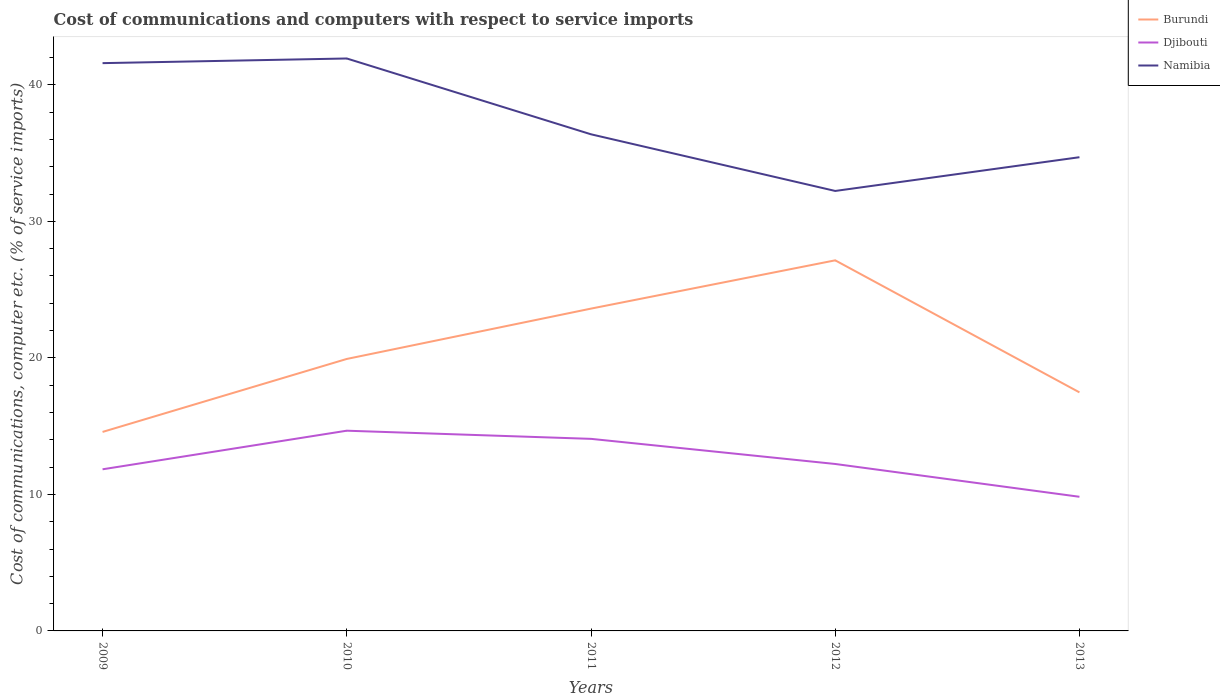How many different coloured lines are there?
Offer a terse response. 3. Across all years, what is the maximum cost of communications and computers in Namibia?
Make the answer very short. 32.23. In which year was the cost of communications and computers in Djibouti maximum?
Your response must be concise. 2013. What is the total cost of communications and computers in Djibouti in the graph?
Your answer should be very brief. -2.23. What is the difference between the highest and the second highest cost of communications and computers in Burundi?
Provide a short and direct response. 12.57. Is the cost of communications and computers in Burundi strictly greater than the cost of communications and computers in Djibouti over the years?
Ensure brevity in your answer.  No. How many years are there in the graph?
Ensure brevity in your answer.  5. Are the values on the major ticks of Y-axis written in scientific E-notation?
Your answer should be very brief. No. Does the graph contain grids?
Provide a short and direct response. No. Where does the legend appear in the graph?
Give a very brief answer. Top right. How many legend labels are there?
Keep it short and to the point. 3. How are the legend labels stacked?
Offer a very short reply. Vertical. What is the title of the graph?
Ensure brevity in your answer.  Cost of communications and computers with respect to service imports. What is the label or title of the X-axis?
Your answer should be very brief. Years. What is the label or title of the Y-axis?
Offer a terse response. Cost of communications, computer etc. (% of service imports). What is the Cost of communications, computer etc. (% of service imports) of Burundi in 2009?
Offer a very short reply. 14.58. What is the Cost of communications, computer etc. (% of service imports) of Djibouti in 2009?
Provide a short and direct response. 11.84. What is the Cost of communications, computer etc. (% of service imports) of Namibia in 2009?
Ensure brevity in your answer.  41.59. What is the Cost of communications, computer etc. (% of service imports) of Burundi in 2010?
Offer a terse response. 19.92. What is the Cost of communications, computer etc. (% of service imports) in Djibouti in 2010?
Give a very brief answer. 14.67. What is the Cost of communications, computer etc. (% of service imports) in Namibia in 2010?
Ensure brevity in your answer.  41.93. What is the Cost of communications, computer etc. (% of service imports) in Burundi in 2011?
Keep it short and to the point. 23.61. What is the Cost of communications, computer etc. (% of service imports) in Djibouti in 2011?
Your answer should be compact. 14.07. What is the Cost of communications, computer etc. (% of service imports) in Namibia in 2011?
Your response must be concise. 36.38. What is the Cost of communications, computer etc. (% of service imports) of Burundi in 2012?
Make the answer very short. 27.15. What is the Cost of communications, computer etc. (% of service imports) in Djibouti in 2012?
Make the answer very short. 12.23. What is the Cost of communications, computer etc. (% of service imports) of Namibia in 2012?
Provide a short and direct response. 32.23. What is the Cost of communications, computer etc. (% of service imports) of Burundi in 2013?
Your answer should be compact. 17.48. What is the Cost of communications, computer etc. (% of service imports) in Djibouti in 2013?
Provide a short and direct response. 9.83. What is the Cost of communications, computer etc. (% of service imports) in Namibia in 2013?
Make the answer very short. 34.7. Across all years, what is the maximum Cost of communications, computer etc. (% of service imports) of Burundi?
Give a very brief answer. 27.15. Across all years, what is the maximum Cost of communications, computer etc. (% of service imports) of Djibouti?
Give a very brief answer. 14.67. Across all years, what is the maximum Cost of communications, computer etc. (% of service imports) in Namibia?
Your response must be concise. 41.93. Across all years, what is the minimum Cost of communications, computer etc. (% of service imports) in Burundi?
Offer a terse response. 14.58. Across all years, what is the minimum Cost of communications, computer etc. (% of service imports) of Djibouti?
Provide a short and direct response. 9.83. Across all years, what is the minimum Cost of communications, computer etc. (% of service imports) in Namibia?
Ensure brevity in your answer.  32.23. What is the total Cost of communications, computer etc. (% of service imports) in Burundi in the graph?
Ensure brevity in your answer.  102.73. What is the total Cost of communications, computer etc. (% of service imports) in Djibouti in the graph?
Provide a succinct answer. 62.63. What is the total Cost of communications, computer etc. (% of service imports) in Namibia in the graph?
Offer a very short reply. 186.83. What is the difference between the Cost of communications, computer etc. (% of service imports) of Burundi in 2009 and that in 2010?
Offer a very short reply. -5.35. What is the difference between the Cost of communications, computer etc. (% of service imports) in Djibouti in 2009 and that in 2010?
Provide a succinct answer. -2.83. What is the difference between the Cost of communications, computer etc. (% of service imports) of Namibia in 2009 and that in 2010?
Provide a short and direct response. -0.34. What is the difference between the Cost of communications, computer etc. (% of service imports) of Burundi in 2009 and that in 2011?
Provide a succinct answer. -9.03. What is the difference between the Cost of communications, computer etc. (% of service imports) in Djibouti in 2009 and that in 2011?
Ensure brevity in your answer.  -2.23. What is the difference between the Cost of communications, computer etc. (% of service imports) in Namibia in 2009 and that in 2011?
Give a very brief answer. 5.21. What is the difference between the Cost of communications, computer etc. (% of service imports) in Burundi in 2009 and that in 2012?
Your response must be concise. -12.57. What is the difference between the Cost of communications, computer etc. (% of service imports) in Djibouti in 2009 and that in 2012?
Your response must be concise. -0.39. What is the difference between the Cost of communications, computer etc. (% of service imports) in Namibia in 2009 and that in 2012?
Ensure brevity in your answer.  9.36. What is the difference between the Cost of communications, computer etc. (% of service imports) in Burundi in 2009 and that in 2013?
Provide a short and direct response. -2.9. What is the difference between the Cost of communications, computer etc. (% of service imports) in Djibouti in 2009 and that in 2013?
Your response must be concise. 2.01. What is the difference between the Cost of communications, computer etc. (% of service imports) of Namibia in 2009 and that in 2013?
Make the answer very short. 6.89. What is the difference between the Cost of communications, computer etc. (% of service imports) in Burundi in 2010 and that in 2011?
Your answer should be very brief. -3.69. What is the difference between the Cost of communications, computer etc. (% of service imports) of Djibouti in 2010 and that in 2011?
Ensure brevity in your answer.  0.6. What is the difference between the Cost of communications, computer etc. (% of service imports) in Namibia in 2010 and that in 2011?
Keep it short and to the point. 5.55. What is the difference between the Cost of communications, computer etc. (% of service imports) in Burundi in 2010 and that in 2012?
Your answer should be compact. -7.22. What is the difference between the Cost of communications, computer etc. (% of service imports) of Djibouti in 2010 and that in 2012?
Make the answer very short. 2.44. What is the difference between the Cost of communications, computer etc. (% of service imports) of Namibia in 2010 and that in 2012?
Your response must be concise. 9.7. What is the difference between the Cost of communications, computer etc. (% of service imports) in Burundi in 2010 and that in 2013?
Offer a terse response. 2.45. What is the difference between the Cost of communications, computer etc. (% of service imports) in Djibouti in 2010 and that in 2013?
Keep it short and to the point. 4.84. What is the difference between the Cost of communications, computer etc. (% of service imports) of Namibia in 2010 and that in 2013?
Provide a short and direct response. 7.23. What is the difference between the Cost of communications, computer etc. (% of service imports) in Burundi in 2011 and that in 2012?
Your answer should be very brief. -3.54. What is the difference between the Cost of communications, computer etc. (% of service imports) in Djibouti in 2011 and that in 2012?
Provide a succinct answer. 1.84. What is the difference between the Cost of communications, computer etc. (% of service imports) of Namibia in 2011 and that in 2012?
Provide a short and direct response. 4.15. What is the difference between the Cost of communications, computer etc. (% of service imports) of Burundi in 2011 and that in 2013?
Provide a succinct answer. 6.14. What is the difference between the Cost of communications, computer etc. (% of service imports) in Djibouti in 2011 and that in 2013?
Give a very brief answer. 4.24. What is the difference between the Cost of communications, computer etc. (% of service imports) in Namibia in 2011 and that in 2013?
Your answer should be compact. 1.68. What is the difference between the Cost of communications, computer etc. (% of service imports) in Burundi in 2012 and that in 2013?
Offer a very short reply. 9.67. What is the difference between the Cost of communications, computer etc. (% of service imports) in Djibouti in 2012 and that in 2013?
Offer a terse response. 2.4. What is the difference between the Cost of communications, computer etc. (% of service imports) of Namibia in 2012 and that in 2013?
Make the answer very short. -2.47. What is the difference between the Cost of communications, computer etc. (% of service imports) in Burundi in 2009 and the Cost of communications, computer etc. (% of service imports) in Djibouti in 2010?
Ensure brevity in your answer.  -0.09. What is the difference between the Cost of communications, computer etc. (% of service imports) of Burundi in 2009 and the Cost of communications, computer etc. (% of service imports) of Namibia in 2010?
Your response must be concise. -27.36. What is the difference between the Cost of communications, computer etc. (% of service imports) of Djibouti in 2009 and the Cost of communications, computer etc. (% of service imports) of Namibia in 2010?
Your answer should be very brief. -30.09. What is the difference between the Cost of communications, computer etc. (% of service imports) of Burundi in 2009 and the Cost of communications, computer etc. (% of service imports) of Djibouti in 2011?
Keep it short and to the point. 0.51. What is the difference between the Cost of communications, computer etc. (% of service imports) in Burundi in 2009 and the Cost of communications, computer etc. (% of service imports) in Namibia in 2011?
Your answer should be compact. -21.8. What is the difference between the Cost of communications, computer etc. (% of service imports) of Djibouti in 2009 and the Cost of communications, computer etc. (% of service imports) of Namibia in 2011?
Offer a very short reply. -24.54. What is the difference between the Cost of communications, computer etc. (% of service imports) in Burundi in 2009 and the Cost of communications, computer etc. (% of service imports) in Djibouti in 2012?
Your answer should be compact. 2.35. What is the difference between the Cost of communications, computer etc. (% of service imports) of Burundi in 2009 and the Cost of communications, computer etc. (% of service imports) of Namibia in 2012?
Your answer should be compact. -17.65. What is the difference between the Cost of communications, computer etc. (% of service imports) of Djibouti in 2009 and the Cost of communications, computer etc. (% of service imports) of Namibia in 2012?
Provide a short and direct response. -20.39. What is the difference between the Cost of communications, computer etc. (% of service imports) of Burundi in 2009 and the Cost of communications, computer etc. (% of service imports) of Djibouti in 2013?
Ensure brevity in your answer.  4.75. What is the difference between the Cost of communications, computer etc. (% of service imports) of Burundi in 2009 and the Cost of communications, computer etc. (% of service imports) of Namibia in 2013?
Your answer should be compact. -20.12. What is the difference between the Cost of communications, computer etc. (% of service imports) in Djibouti in 2009 and the Cost of communications, computer etc. (% of service imports) in Namibia in 2013?
Offer a very short reply. -22.86. What is the difference between the Cost of communications, computer etc. (% of service imports) in Burundi in 2010 and the Cost of communications, computer etc. (% of service imports) in Djibouti in 2011?
Offer a terse response. 5.85. What is the difference between the Cost of communications, computer etc. (% of service imports) of Burundi in 2010 and the Cost of communications, computer etc. (% of service imports) of Namibia in 2011?
Your answer should be compact. -16.46. What is the difference between the Cost of communications, computer etc. (% of service imports) in Djibouti in 2010 and the Cost of communications, computer etc. (% of service imports) in Namibia in 2011?
Your answer should be compact. -21.71. What is the difference between the Cost of communications, computer etc. (% of service imports) of Burundi in 2010 and the Cost of communications, computer etc. (% of service imports) of Djibouti in 2012?
Your answer should be compact. 7.69. What is the difference between the Cost of communications, computer etc. (% of service imports) in Burundi in 2010 and the Cost of communications, computer etc. (% of service imports) in Namibia in 2012?
Offer a very short reply. -12.31. What is the difference between the Cost of communications, computer etc. (% of service imports) of Djibouti in 2010 and the Cost of communications, computer etc. (% of service imports) of Namibia in 2012?
Provide a succinct answer. -17.56. What is the difference between the Cost of communications, computer etc. (% of service imports) in Burundi in 2010 and the Cost of communications, computer etc. (% of service imports) in Djibouti in 2013?
Your answer should be compact. 10.1. What is the difference between the Cost of communications, computer etc. (% of service imports) of Burundi in 2010 and the Cost of communications, computer etc. (% of service imports) of Namibia in 2013?
Offer a terse response. -14.78. What is the difference between the Cost of communications, computer etc. (% of service imports) of Djibouti in 2010 and the Cost of communications, computer etc. (% of service imports) of Namibia in 2013?
Make the answer very short. -20.03. What is the difference between the Cost of communications, computer etc. (% of service imports) in Burundi in 2011 and the Cost of communications, computer etc. (% of service imports) in Djibouti in 2012?
Your answer should be compact. 11.38. What is the difference between the Cost of communications, computer etc. (% of service imports) in Burundi in 2011 and the Cost of communications, computer etc. (% of service imports) in Namibia in 2012?
Your answer should be very brief. -8.62. What is the difference between the Cost of communications, computer etc. (% of service imports) in Djibouti in 2011 and the Cost of communications, computer etc. (% of service imports) in Namibia in 2012?
Ensure brevity in your answer.  -18.16. What is the difference between the Cost of communications, computer etc. (% of service imports) in Burundi in 2011 and the Cost of communications, computer etc. (% of service imports) in Djibouti in 2013?
Give a very brief answer. 13.78. What is the difference between the Cost of communications, computer etc. (% of service imports) of Burundi in 2011 and the Cost of communications, computer etc. (% of service imports) of Namibia in 2013?
Give a very brief answer. -11.09. What is the difference between the Cost of communications, computer etc. (% of service imports) of Djibouti in 2011 and the Cost of communications, computer etc. (% of service imports) of Namibia in 2013?
Make the answer very short. -20.63. What is the difference between the Cost of communications, computer etc. (% of service imports) in Burundi in 2012 and the Cost of communications, computer etc. (% of service imports) in Djibouti in 2013?
Make the answer very short. 17.32. What is the difference between the Cost of communications, computer etc. (% of service imports) in Burundi in 2012 and the Cost of communications, computer etc. (% of service imports) in Namibia in 2013?
Your answer should be compact. -7.55. What is the difference between the Cost of communications, computer etc. (% of service imports) in Djibouti in 2012 and the Cost of communications, computer etc. (% of service imports) in Namibia in 2013?
Offer a very short reply. -22.47. What is the average Cost of communications, computer etc. (% of service imports) in Burundi per year?
Your answer should be compact. 20.55. What is the average Cost of communications, computer etc. (% of service imports) in Djibouti per year?
Ensure brevity in your answer.  12.53. What is the average Cost of communications, computer etc. (% of service imports) of Namibia per year?
Your answer should be compact. 37.37. In the year 2009, what is the difference between the Cost of communications, computer etc. (% of service imports) in Burundi and Cost of communications, computer etc. (% of service imports) in Djibouti?
Offer a terse response. 2.74. In the year 2009, what is the difference between the Cost of communications, computer etc. (% of service imports) in Burundi and Cost of communications, computer etc. (% of service imports) in Namibia?
Keep it short and to the point. -27.01. In the year 2009, what is the difference between the Cost of communications, computer etc. (% of service imports) of Djibouti and Cost of communications, computer etc. (% of service imports) of Namibia?
Your response must be concise. -29.75. In the year 2010, what is the difference between the Cost of communications, computer etc. (% of service imports) of Burundi and Cost of communications, computer etc. (% of service imports) of Djibouti?
Offer a terse response. 5.26. In the year 2010, what is the difference between the Cost of communications, computer etc. (% of service imports) in Burundi and Cost of communications, computer etc. (% of service imports) in Namibia?
Ensure brevity in your answer.  -22.01. In the year 2010, what is the difference between the Cost of communications, computer etc. (% of service imports) in Djibouti and Cost of communications, computer etc. (% of service imports) in Namibia?
Your answer should be very brief. -27.27. In the year 2011, what is the difference between the Cost of communications, computer etc. (% of service imports) of Burundi and Cost of communications, computer etc. (% of service imports) of Djibouti?
Your answer should be compact. 9.54. In the year 2011, what is the difference between the Cost of communications, computer etc. (% of service imports) in Burundi and Cost of communications, computer etc. (% of service imports) in Namibia?
Ensure brevity in your answer.  -12.77. In the year 2011, what is the difference between the Cost of communications, computer etc. (% of service imports) of Djibouti and Cost of communications, computer etc. (% of service imports) of Namibia?
Ensure brevity in your answer.  -22.31. In the year 2012, what is the difference between the Cost of communications, computer etc. (% of service imports) of Burundi and Cost of communications, computer etc. (% of service imports) of Djibouti?
Your answer should be compact. 14.92. In the year 2012, what is the difference between the Cost of communications, computer etc. (% of service imports) of Burundi and Cost of communications, computer etc. (% of service imports) of Namibia?
Provide a short and direct response. -5.08. In the year 2012, what is the difference between the Cost of communications, computer etc. (% of service imports) in Djibouti and Cost of communications, computer etc. (% of service imports) in Namibia?
Ensure brevity in your answer.  -20. In the year 2013, what is the difference between the Cost of communications, computer etc. (% of service imports) in Burundi and Cost of communications, computer etc. (% of service imports) in Djibouti?
Ensure brevity in your answer.  7.65. In the year 2013, what is the difference between the Cost of communications, computer etc. (% of service imports) of Burundi and Cost of communications, computer etc. (% of service imports) of Namibia?
Give a very brief answer. -17.23. In the year 2013, what is the difference between the Cost of communications, computer etc. (% of service imports) in Djibouti and Cost of communications, computer etc. (% of service imports) in Namibia?
Give a very brief answer. -24.87. What is the ratio of the Cost of communications, computer etc. (% of service imports) of Burundi in 2009 to that in 2010?
Provide a short and direct response. 0.73. What is the ratio of the Cost of communications, computer etc. (% of service imports) in Djibouti in 2009 to that in 2010?
Your response must be concise. 0.81. What is the ratio of the Cost of communications, computer etc. (% of service imports) in Namibia in 2009 to that in 2010?
Ensure brevity in your answer.  0.99. What is the ratio of the Cost of communications, computer etc. (% of service imports) of Burundi in 2009 to that in 2011?
Provide a short and direct response. 0.62. What is the ratio of the Cost of communications, computer etc. (% of service imports) of Djibouti in 2009 to that in 2011?
Offer a very short reply. 0.84. What is the ratio of the Cost of communications, computer etc. (% of service imports) in Namibia in 2009 to that in 2011?
Keep it short and to the point. 1.14. What is the ratio of the Cost of communications, computer etc. (% of service imports) in Burundi in 2009 to that in 2012?
Offer a terse response. 0.54. What is the ratio of the Cost of communications, computer etc. (% of service imports) of Djibouti in 2009 to that in 2012?
Provide a short and direct response. 0.97. What is the ratio of the Cost of communications, computer etc. (% of service imports) of Namibia in 2009 to that in 2012?
Keep it short and to the point. 1.29. What is the ratio of the Cost of communications, computer etc. (% of service imports) in Burundi in 2009 to that in 2013?
Offer a terse response. 0.83. What is the ratio of the Cost of communications, computer etc. (% of service imports) in Djibouti in 2009 to that in 2013?
Offer a terse response. 1.2. What is the ratio of the Cost of communications, computer etc. (% of service imports) in Namibia in 2009 to that in 2013?
Keep it short and to the point. 1.2. What is the ratio of the Cost of communications, computer etc. (% of service imports) in Burundi in 2010 to that in 2011?
Your response must be concise. 0.84. What is the ratio of the Cost of communications, computer etc. (% of service imports) of Djibouti in 2010 to that in 2011?
Offer a very short reply. 1.04. What is the ratio of the Cost of communications, computer etc. (% of service imports) in Namibia in 2010 to that in 2011?
Give a very brief answer. 1.15. What is the ratio of the Cost of communications, computer etc. (% of service imports) of Burundi in 2010 to that in 2012?
Provide a short and direct response. 0.73. What is the ratio of the Cost of communications, computer etc. (% of service imports) in Djibouti in 2010 to that in 2012?
Provide a short and direct response. 1.2. What is the ratio of the Cost of communications, computer etc. (% of service imports) in Namibia in 2010 to that in 2012?
Your answer should be compact. 1.3. What is the ratio of the Cost of communications, computer etc. (% of service imports) of Burundi in 2010 to that in 2013?
Your answer should be very brief. 1.14. What is the ratio of the Cost of communications, computer etc. (% of service imports) in Djibouti in 2010 to that in 2013?
Your response must be concise. 1.49. What is the ratio of the Cost of communications, computer etc. (% of service imports) in Namibia in 2010 to that in 2013?
Your response must be concise. 1.21. What is the ratio of the Cost of communications, computer etc. (% of service imports) of Burundi in 2011 to that in 2012?
Offer a very short reply. 0.87. What is the ratio of the Cost of communications, computer etc. (% of service imports) of Djibouti in 2011 to that in 2012?
Your response must be concise. 1.15. What is the ratio of the Cost of communications, computer etc. (% of service imports) of Namibia in 2011 to that in 2012?
Your response must be concise. 1.13. What is the ratio of the Cost of communications, computer etc. (% of service imports) in Burundi in 2011 to that in 2013?
Your response must be concise. 1.35. What is the ratio of the Cost of communications, computer etc. (% of service imports) of Djibouti in 2011 to that in 2013?
Your answer should be compact. 1.43. What is the ratio of the Cost of communications, computer etc. (% of service imports) in Namibia in 2011 to that in 2013?
Your answer should be compact. 1.05. What is the ratio of the Cost of communications, computer etc. (% of service imports) in Burundi in 2012 to that in 2013?
Offer a terse response. 1.55. What is the ratio of the Cost of communications, computer etc. (% of service imports) in Djibouti in 2012 to that in 2013?
Ensure brevity in your answer.  1.24. What is the ratio of the Cost of communications, computer etc. (% of service imports) of Namibia in 2012 to that in 2013?
Your answer should be very brief. 0.93. What is the difference between the highest and the second highest Cost of communications, computer etc. (% of service imports) in Burundi?
Keep it short and to the point. 3.54. What is the difference between the highest and the second highest Cost of communications, computer etc. (% of service imports) in Djibouti?
Your response must be concise. 0.6. What is the difference between the highest and the second highest Cost of communications, computer etc. (% of service imports) of Namibia?
Keep it short and to the point. 0.34. What is the difference between the highest and the lowest Cost of communications, computer etc. (% of service imports) in Burundi?
Provide a short and direct response. 12.57. What is the difference between the highest and the lowest Cost of communications, computer etc. (% of service imports) in Djibouti?
Your answer should be very brief. 4.84. What is the difference between the highest and the lowest Cost of communications, computer etc. (% of service imports) in Namibia?
Offer a terse response. 9.7. 